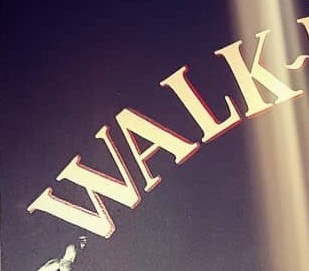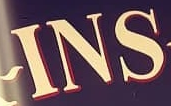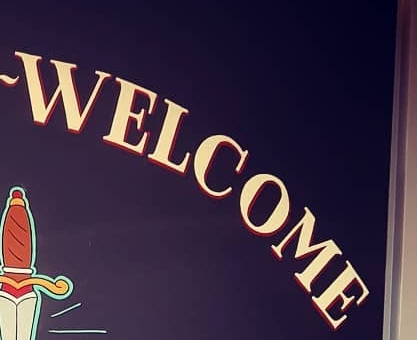What text is displayed in these images sequentially, separated by a semicolon? WALK; INS; WELCOME 